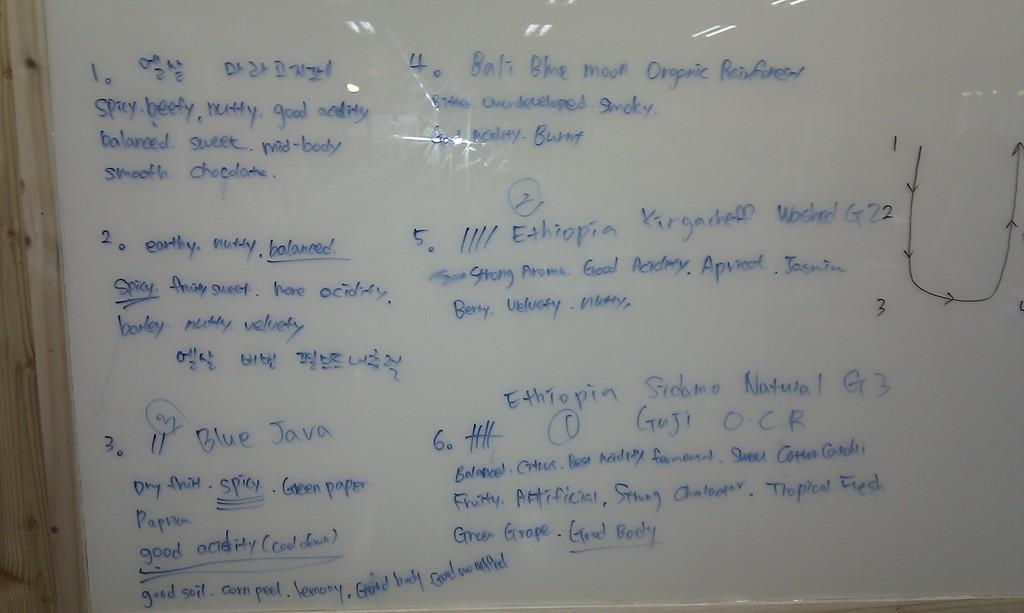<image>
Share a concise interpretation of the image provided. a whiteboard  with the words 'spicy, beefy, nutty' written on it. 